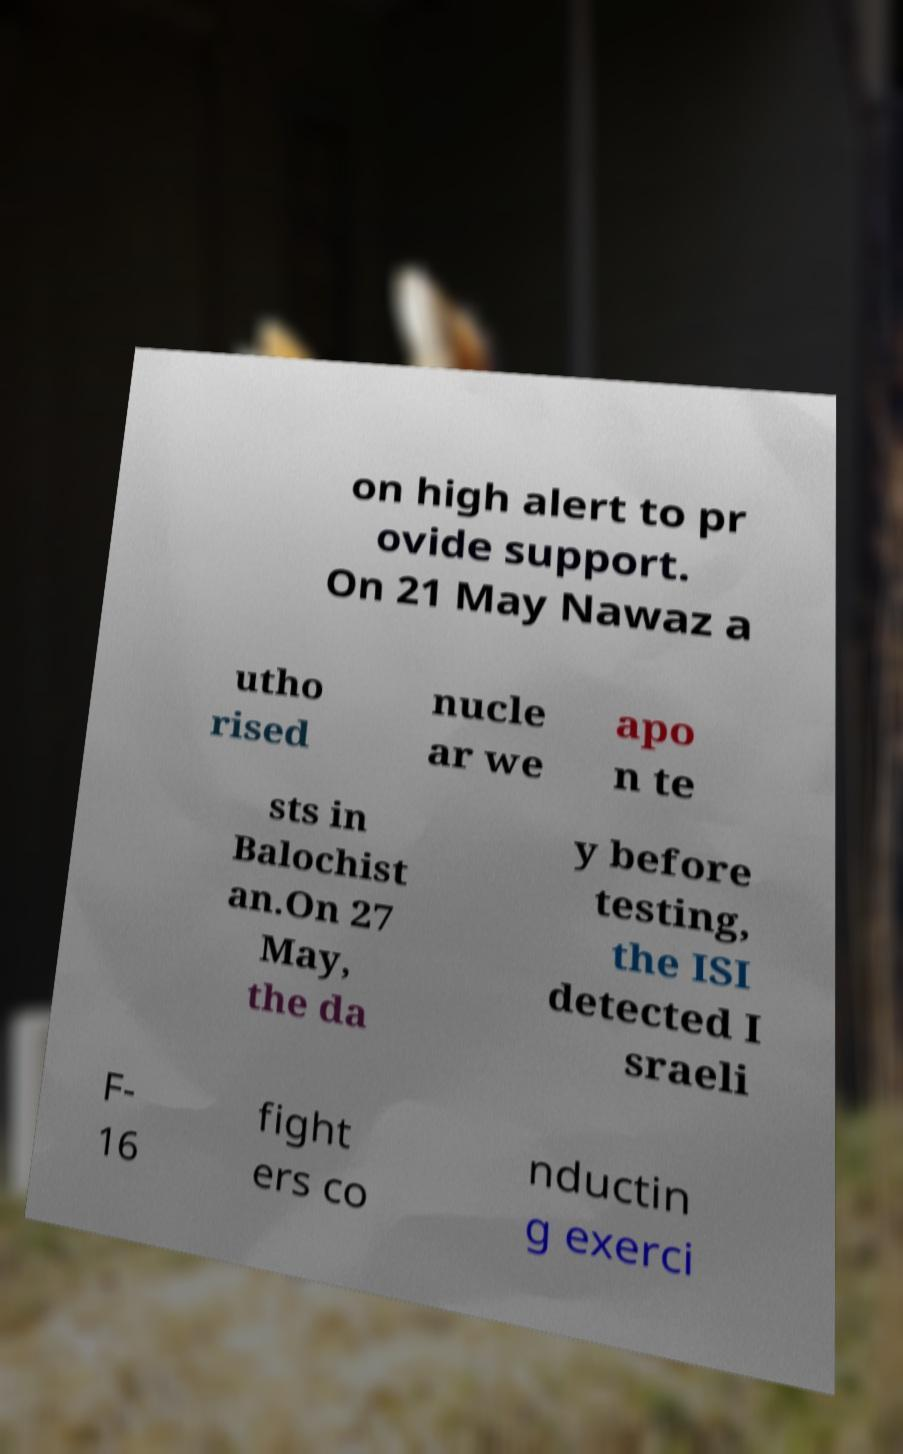Could you assist in decoding the text presented in this image and type it out clearly? on high alert to pr ovide support. On 21 May Nawaz a utho rised nucle ar we apo n te sts in Balochist an.On 27 May, the da y before testing, the ISI detected I sraeli F- 16 fight ers co nductin g exerci 